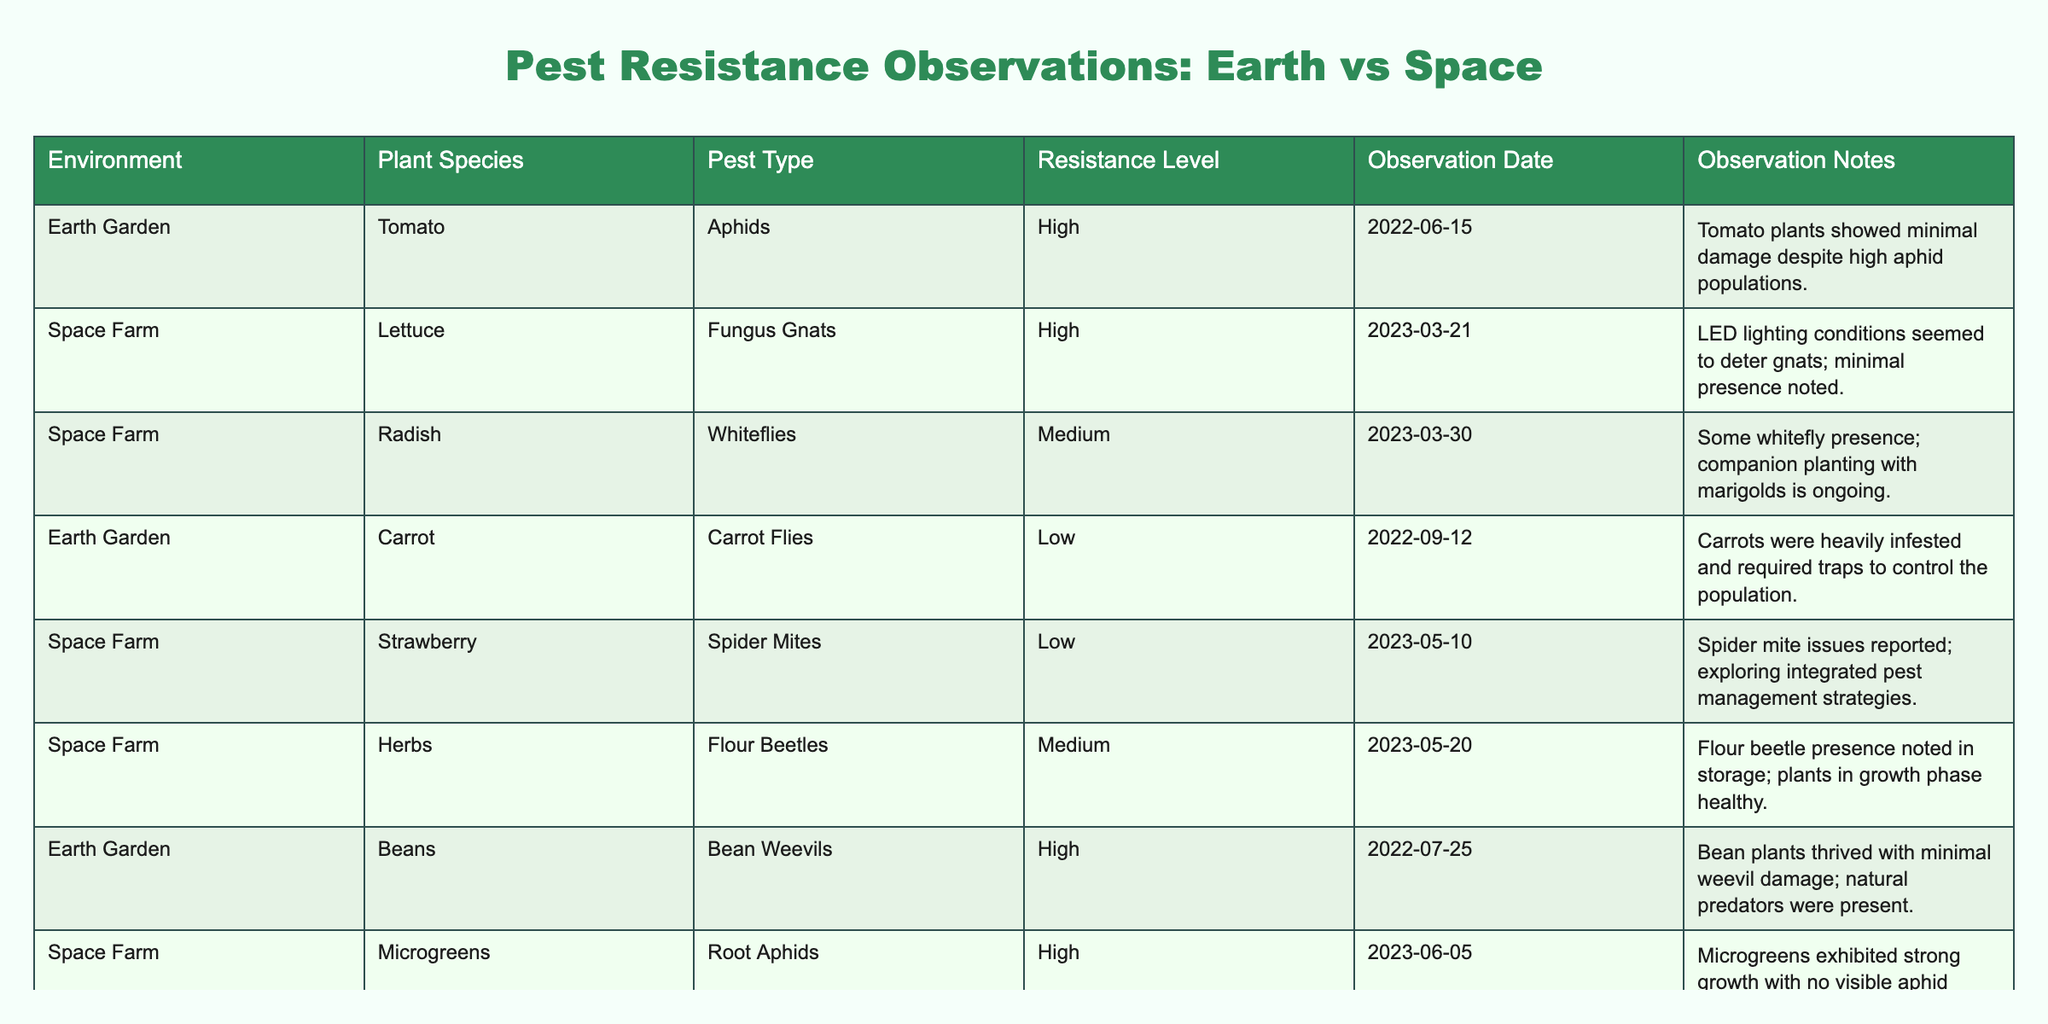What is the resistance level of Tomato plants in Earth Gardens? The table indicates that Tomato plants in Earth Gardens have a resistance level to Aphids classified as 'High'.
Answer: High How many plant species are recorded in the Space Farm environment? In the Space Farm section of the table, there are four distinct plant species listed: Lettuce, Radish, Strawberry, and Microgreens.
Answer: 4 Which pest type affected Carrots in the Earth Garden? According to the table, Carrots in the Earth Garden were affected by Carrot Flies.
Answer: Carrot Flies Did any plants in the Space Farm have a low resistance level? The table reveals that both Strawberry (Spider Mites) and Radish (Whiteflies) have a low resistance level in the Space Farm environment.
Answer: Yes What observation date corresponds to the resistance level of Herbs against Flour Beetles? The observation date for Herbs against Flour Beetles in the Space Farm is 2023-05-20.
Answer: 2023-05-20 Comparing the resistance levels in Earth Gardens to Space Farms, which had more high resistance observations? In the Earth Gardens, there are two high resistance observations (Tomato and Beans), while in the Space Farms, there are three (Lettuce, Microgreens, and Beans). Thus, Space Farms have more high resistance observations.
Answer: Space Farms have more Which observation note suggests using integrated pest management strategies? The observation note for Strawberry in the Space Farm states that spider mite issues were reported and that integrated pest management strategies are being explored.
Answer: Strawberry, Space Farm How many pest types have been recorded in Earth Gardens? The table lists four distinct pest types affecting plants in Earth Gardens: Aphids, Carrot Flies, Bean Weevils, and the observation counts total to four.
Answer: 4 Is there a plant species in the Space Farm with a medium resistance level? Yes, the table shows both Radish (Whiteflies) and Herbs (Flour Beetles) listed with a medium resistance level in the Space Farm environment.
Answer: Yes What is the average resistance level across all plants in Earth Gardens? Earth Gardens have two high (Tomato, Beans), one low (Carrot), and no medium level, giving an average resistance level of High (2), Low (1) = 2/3 high = Average High
Answer: High What conclusions can be drawn from the observation notes about pest management in Space Farms? The observation notes indicate proactive approaches in Space Farms, such as controlling gnat populations through LED lighting for lettuce and exploring integrated pest management for strawberries, reflecting innovative solutions.
Answer: Proactive pest management strategies 